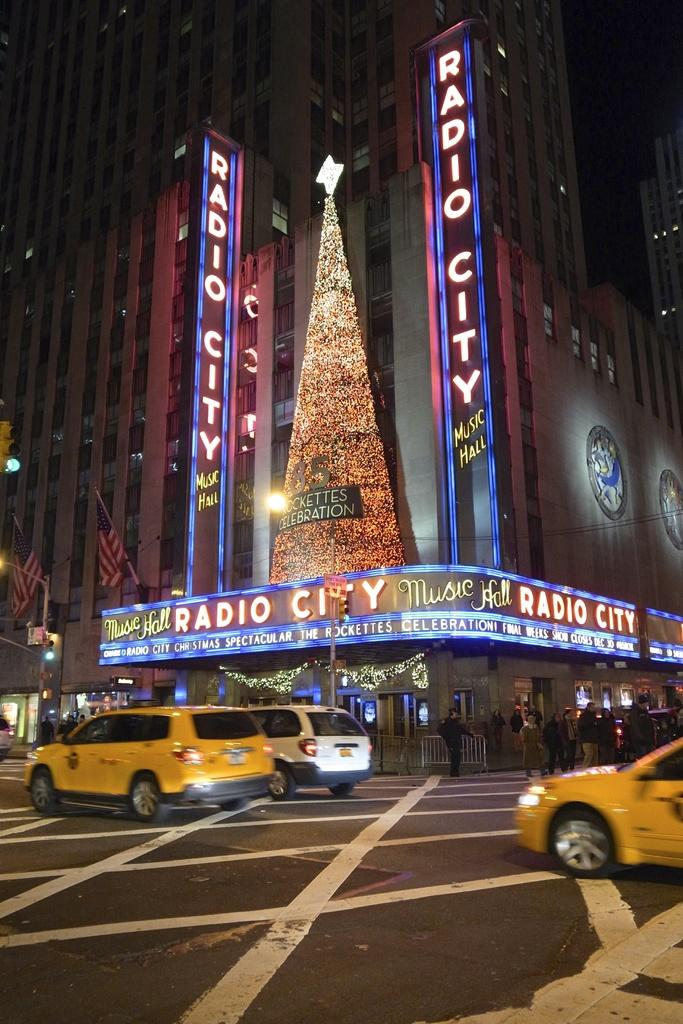Provide a one-sentence caption for the provided image. The Rocketts performing at Radio City with a sign saying the show closes Dec 30. 